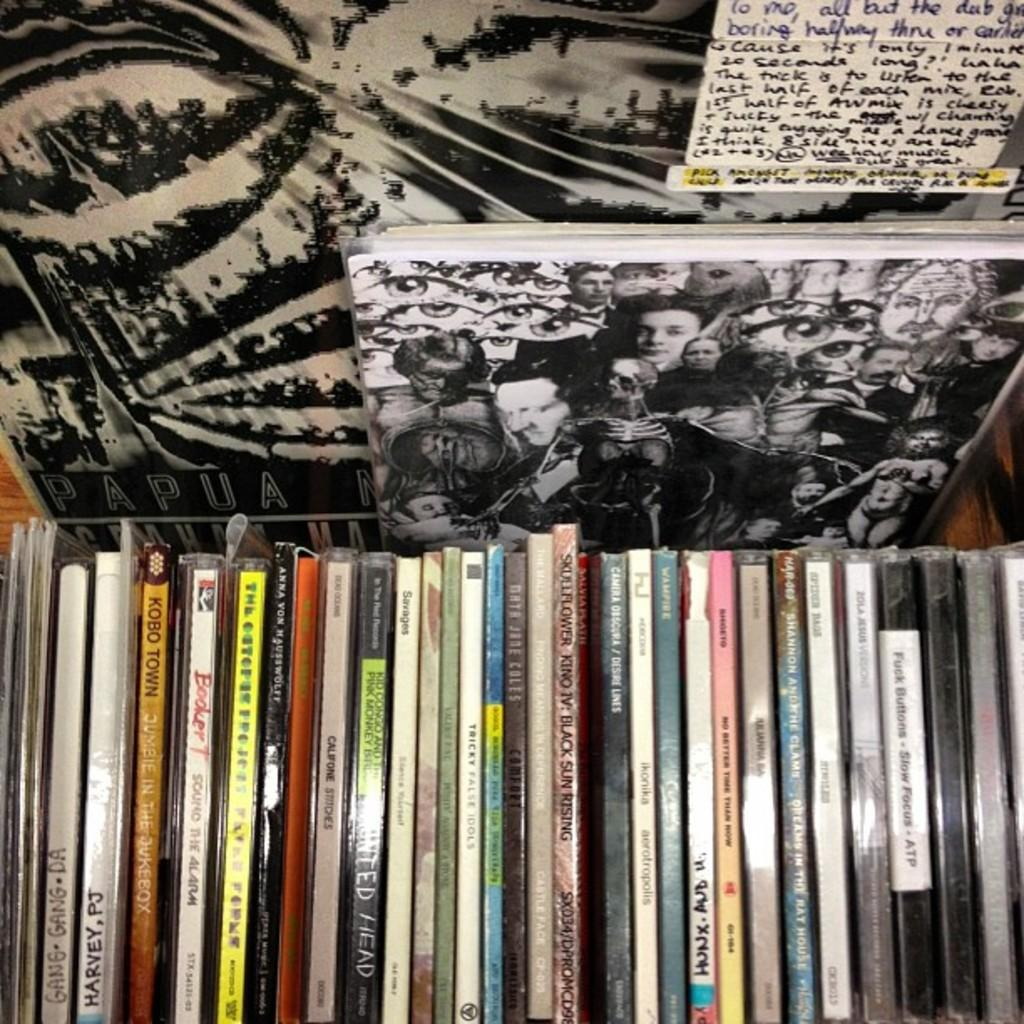<image>
Describe the image concisely. A bunch of CD's are stacked side by side with PJ Harvey and Skullflower being a few 